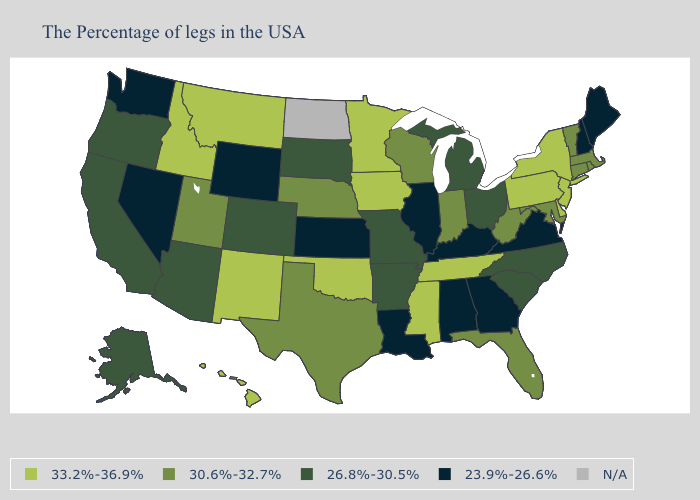Name the states that have a value in the range 30.6%-32.7%?
Quick response, please. Massachusetts, Rhode Island, Vermont, Connecticut, Maryland, West Virginia, Florida, Indiana, Wisconsin, Nebraska, Texas, Utah. What is the highest value in the South ?
Quick response, please. 33.2%-36.9%. What is the lowest value in states that border New Jersey?
Give a very brief answer. 33.2%-36.9%. What is the value of Indiana?
Short answer required. 30.6%-32.7%. Which states have the lowest value in the Northeast?
Quick response, please. Maine, New Hampshire. Name the states that have a value in the range N/A?
Write a very short answer. North Dakota. What is the value of Rhode Island?
Be succinct. 30.6%-32.7%. Among the states that border Wisconsin , which have the highest value?
Quick response, please. Minnesota, Iowa. What is the lowest value in states that border Missouri?
Short answer required. 23.9%-26.6%. Among the states that border Louisiana , does Arkansas have the lowest value?
Short answer required. Yes. What is the value of New Hampshire?
Short answer required. 23.9%-26.6%. Name the states that have a value in the range 30.6%-32.7%?
Be succinct. Massachusetts, Rhode Island, Vermont, Connecticut, Maryland, West Virginia, Florida, Indiana, Wisconsin, Nebraska, Texas, Utah. Is the legend a continuous bar?
Short answer required. No. 